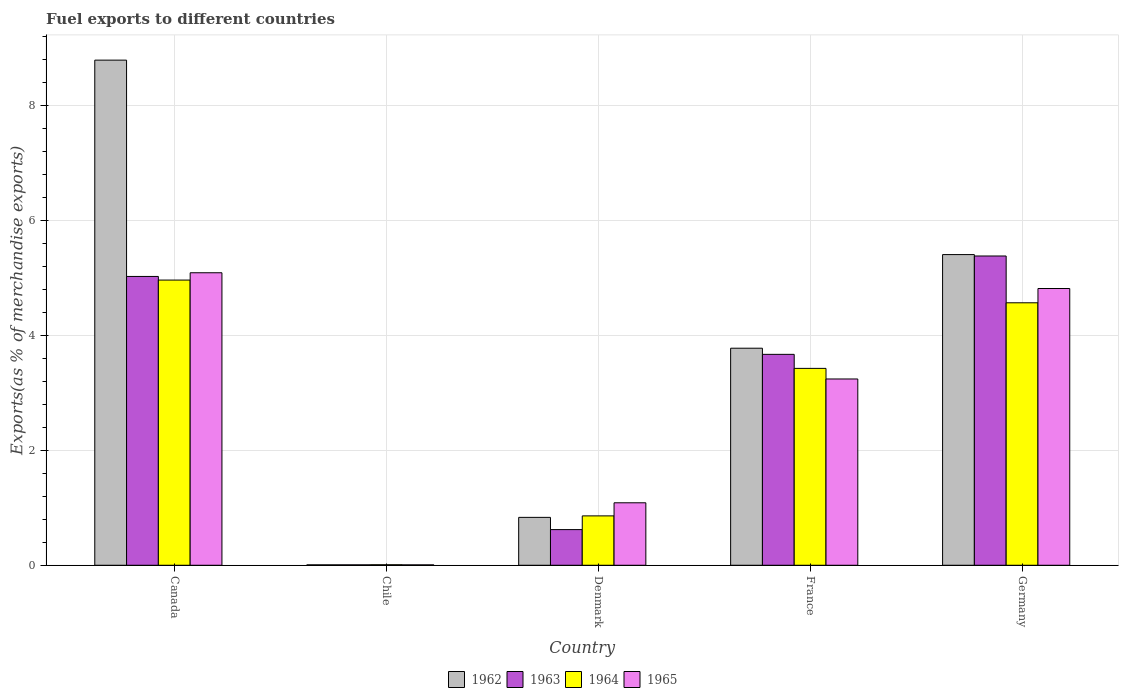Are the number of bars per tick equal to the number of legend labels?
Ensure brevity in your answer.  Yes. Are the number of bars on each tick of the X-axis equal?
Ensure brevity in your answer.  Yes. How many bars are there on the 3rd tick from the left?
Offer a very short reply. 4. How many bars are there on the 5th tick from the right?
Offer a terse response. 4. What is the label of the 1st group of bars from the left?
Keep it short and to the point. Canada. In how many cases, is the number of bars for a given country not equal to the number of legend labels?
Keep it short and to the point. 0. What is the percentage of exports to different countries in 1962 in Denmark?
Provide a succinct answer. 0.83. Across all countries, what is the maximum percentage of exports to different countries in 1963?
Your answer should be compact. 5.38. Across all countries, what is the minimum percentage of exports to different countries in 1965?
Offer a very short reply. 0.01. In which country was the percentage of exports to different countries in 1965 maximum?
Provide a succinct answer. Canada. What is the total percentage of exports to different countries in 1964 in the graph?
Your answer should be very brief. 13.82. What is the difference between the percentage of exports to different countries in 1963 in Canada and that in Germany?
Provide a short and direct response. -0.36. What is the difference between the percentage of exports to different countries in 1962 in Canada and the percentage of exports to different countries in 1963 in Chile?
Provide a short and direct response. 8.78. What is the average percentage of exports to different countries in 1962 per country?
Ensure brevity in your answer.  3.76. What is the difference between the percentage of exports to different countries of/in 1965 and percentage of exports to different countries of/in 1964 in Canada?
Your answer should be very brief. 0.13. What is the ratio of the percentage of exports to different countries in 1964 in Canada to that in Denmark?
Offer a very short reply. 5.78. Is the percentage of exports to different countries in 1965 in Chile less than that in France?
Provide a short and direct response. Yes. Is the difference between the percentage of exports to different countries in 1965 in France and Germany greater than the difference between the percentage of exports to different countries in 1964 in France and Germany?
Provide a succinct answer. No. What is the difference between the highest and the second highest percentage of exports to different countries in 1962?
Make the answer very short. 5.01. What is the difference between the highest and the lowest percentage of exports to different countries in 1963?
Your answer should be very brief. 5.37. In how many countries, is the percentage of exports to different countries in 1962 greater than the average percentage of exports to different countries in 1962 taken over all countries?
Your response must be concise. 3. Is it the case that in every country, the sum of the percentage of exports to different countries in 1962 and percentage of exports to different countries in 1963 is greater than the sum of percentage of exports to different countries in 1964 and percentage of exports to different countries in 1965?
Keep it short and to the point. No. What does the 2nd bar from the left in Canada represents?
Provide a succinct answer. 1963. Is it the case that in every country, the sum of the percentage of exports to different countries in 1962 and percentage of exports to different countries in 1964 is greater than the percentage of exports to different countries in 1965?
Provide a succinct answer. Yes. How many bars are there?
Your answer should be very brief. 20. What is the difference between two consecutive major ticks on the Y-axis?
Your answer should be very brief. 2. Are the values on the major ticks of Y-axis written in scientific E-notation?
Provide a succinct answer. No. Does the graph contain any zero values?
Offer a very short reply. No. Does the graph contain grids?
Offer a very short reply. Yes. How many legend labels are there?
Provide a short and direct response. 4. How are the legend labels stacked?
Ensure brevity in your answer.  Horizontal. What is the title of the graph?
Offer a terse response. Fuel exports to different countries. Does "1972" appear as one of the legend labels in the graph?
Make the answer very short. No. What is the label or title of the Y-axis?
Provide a short and direct response. Exports(as % of merchandise exports). What is the Exports(as % of merchandise exports) in 1962 in Canada?
Keep it short and to the point. 8.79. What is the Exports(as % of merchandise exports) in 1963 in Canada?
Give a very brief answer. 5.02. What is the Exports(as % of merchandise exports) of 1964 in Canada?
Keep it short and to the point. 4.96. What is the Exports(as % of merchandise exports) of 1965 in Canada?
Make the answer very short. 5.09. What is the Exports(as % of merchandise exports) in 1962 in Chile?
Your answer should be very brief. 0.01. What is the Exports(as % of merchandise exports) in 1963 in Chile?
Your answer should be very brief. 0.01. What is the Exports(as % of merchandise exports) in 1964 in Chile?
Keep it short and to the point. 0.01. What is the Exports(as % of merchandise exports) of 1965 in Chile?
Keep it short and to the point. 0.01. What is the Exports(as % of merchandise exports) of 1962 in Denmark?
Keep it short and to the point. 0.83. What is the Exports(as % of merchandise exports) of 1963 in Denmark?
Offer a terse response. 0.62. What is the Exports(as % of merchandise exports) in 1964 in Denmark?
Make the answer very short. 0.86. What is the Exports(as % of merchandise exports) in 1965 in Denmark?
Make the answer very short. 1.09. What is the Exports(as % of merchandise exports) of 1962 in France?
Keep it short and to the point. 3.78. What is the Exports(as % of merchandise exports) in 1963 in France?
Ensure brevity in your answer.  3.67. What is the Exports(as % of merchandise exports) of 1964 in France?
Your answer should be compact. 3.43. What is the Exports(as % of merchandise exports) of 1965 in France?
Keep it short and to the point. 3.24. What is the Exports(as % of merchandise exports) of 1962 in Germany?
Provide a short and direct response. 5.4. What is the Exports(as % of merchandise exports) in 1963 in Germany?
Provide a succinct answer. 5.38. What is the Exports(as % of merchandise exports) of 1964 in Germany?
Offer a terse response. 4.57. What is the Exports(as % of merchandise exports) of 1965 in Germany?
Make the answer very short. 4.81. Across all countries, what is the maximum Exports(as % of merchandise exports) in 1962?
Offer a very short reply. 8.79. Across all countries, what is the maximum Exports(as % of merchandise exports) in 1963?
Your answer should be compact. 5.38. Across all countries, what is the maximum Exports(as % of merchandise exports) of 1964?
Offer a terse response. 4.96. Across all countries, what is the maximum Exports(as % of merchandise exports) of 1965?
Keep it short and to the point. 5.09. Across all countries, what is the minimum Exports(as % of merchandise exports) of 1962?
Your answer should be compact. 0.01. Across all countries, what is the minimum Exports(as % of merchandise exports) of 1963?
Your response must be concise. 0.01. Across all countries, what is the minimum Exports(as % of merchandise exports) of 1964?
Your answer should be compact. 0.01. Across all countries, what is the minimum Exports(as % of merchandise exports) of 1965?
Offer a terse response. 0.01. What is the total Exports(as % of merchandise exports) of 1962 in the graph?
Give a very brief answer. 18.81. What is the total Exports(as % of merchandise exports) of 1963 in the graph?
Provide a short and direct response. 14.7. What is the total Exports(as % of merchandise exports) of 1964 in the graph?
Provide a short and direct response. 13.82. What is the total Exports(as % of merchandise exports) of 1965 in the graph?
Give a very brief answer. 14.24. What is the difference between the Exports(as % of merchandise exports) in 1962 in Canada and that in Chile?
Your answer should be very brief. 8.78. What is the difference between the Exports(as % of merchandise exports) of 1963 in Canada and that in Chile?
Offer a very short reply. 5.02. What is the difference between the Exports(as % of merchandise exports) in 1964 in Canada and that in Chile?
Offer a very short reply. 4.95. What is the difference between the Exports(as % of merchandise exports) in 1965 in Canada and that in Chile?
Provide a short and direct response. 5.08. What is the difference between the Exports(as % of merchandise exports) of 1962 in Canada and that in Denmark?
Your response must be concise. 7.95. What is the difference between the Exports(as % of merchandise exports) of 1963 in Canada and that in Denmark?
Your answer should be compact. 4.4. What is the difference between the Exports(as % of merchandise exports) of 1964 in Canada and that in Denmark?
Offer a terse response. 4.1. What is the difference between the Exports(as % of merchandise exports) in 1965 in Canada and that in Denmark?
Give a very brief answer. 4. What is the difference between the Exports(as % of merchandise exports) in 1962 in Canada and that in France?
Your answer should be very brief. 5.01. What is the difference between the Exports(as % of merchandise exports) in 1963 in Canada and that in France?
Give a very brief answer. 1.36. What is the difference between the Exports(as % of merchandise exports) in 1964 in Canada and that in France?
Keep it short and to the point. 1.54. What is the difference between the Exports(as % of merchandise exports) in 1965 in Canada and that in France?
Offer a very short reply. 1.85. What is the difference between the Exports(as % of merchandise exports) of 1962 in Canada and that in Germany?
Give a very brief answer. 3.38. What is the difference between the Exports(as % of merchandise exports) of 1963 in Canada and that in Germany?
Make the answer very short. -0.36. What is the difference between the Exports(as % of merchandise exports) in 1964 in Canada and that in Germany?
Keep it short and to the point. 0.4. What is the difference between the Exports(as % of merchandise exports) of 1965 in Canada and that in Germany?
Your answer should be compact. 0.27. What is the difference between the Exports(as % of merchandise exports) of 1962 in Chile and that in Denmark?
Your response must be concise. -0.83. What is the difference between the Exports(as % of merchandise exports) of 1963 in Chile and that in Denmark?
Provide a succinct answer. -0.61. What is the difference between the Exports(as % of merchandise exports) of 1964 in Chile and that in Denmark?
Offer a terse response. -0.85. What is the difference between the Exports(as % of merchandise exports) in 1965 in Chile and that in Denmark?
Offer a very short reply. -1.08. What is the difference between the Exports(as % of merchandise exports) of 1962 in Chile and that in France?
Provide a succinct answer. -3.77. What is the difference between the Exports(as % of merchandise exports) in 1963 in Chile and that in France?
Your answer should be compact. -3.66. What is the difference between the Exports(as % of merchandise exports) in 1964 in Chile and that in France?
Offer a very short reply. -3.42. What is the difference between the Exports(as % of merchandise exports) of 1965 in Chile and that in France?
Offer a terse response. -3.23. What is the difference between the Exports(as % of merchandise exports) of 1962 in Chile and that in Germany?
Keep it short and to the point. -5.4. What is the difference between the Exports(as % of merchandise exports) in 1963 in Chile and that in Germany?
Keep it short and to the point. -5.37. What is the difference between the Exports(as % of merchandise exports) in 1964 in Chile and that in Germany?
Your answer should be very brief. -4.56. What is the difference between the Exports(as % of merchandise exports) of 1965 in Chile and that in Germany?
Give a very brief answer. -4.81. What is the difference between the Exports(as % of merchandise exports) in 1962 in Denmark and that in France?
Your answer should be very brief. -2.94. What is the difference between the Exports(as % of merchandise exports) of 1963 in Denmark and that in France?
Keep it short and to the point. -3.05. What is the difference between the Exports(as % of merchandise exports) of 1964 in Denmark and that in France?
Your answer should be compact. -2.57. What is the difference between the Exports(as % of merchandise exports) in 1965 in Denmark and that in France?
Make the answer very short. -2.15. What is the difference between the Exports(as % of merchandise exports) in 1962 in Denmark and that in Germany?
Your answer should be very brief. -4.57. What is the difference between the Exports(as % of merchandise exports) of 1963 in Denmark and that in Germany?
Your answer should be very brief. -4.76. What is the difference between the Exports(as % of merchandise exports) in 1964 in Denmark and that in Germany?
Make the answer very short. -3.71. What is the difference between the Exports(as % of merchandise exports) of 1965 in Denmark and that in Germany?
Make the answer very short. -3.73. What is the difference between the Exports(as % of merchandise exports) in 1962 in France and that in Germany?
Provide a short and direct response. -1.63. What is the difference between the Exports(as % of merchandise exports) of 1963 in France and that in Germany?
Offer a very short reply. -1.71. What is the difference between the Exports(as % of merchandise exports) in 1964 in France and that in Germany?
Your response must be concise. -1.14. What is the difference between the Exports(as % of merchandise exports) in 1965 in France and that in Germany?
Provide a succinct answer. -1.57. What is the difference between the Exports(as % of merchandise exports) in 1962 in Canada and the Exports(as % of merchandise exports) in 1963 in Chile?
Your answer should be very brief. 8.78. What is the difference between the Exports(as % of merchandise exports) of 1962 in Canada and the Exports(as % of merchandise exports) of 1964 in Chile?
Ensure brevity in your answer.  8.78. What is the difference between the Exports(as % of merchandise exports) of 1962 in Canada and the Exports(as % of merchandise exports) of 1965 in Chile?
Offer a terse response. 8.78. What is the difference between the Exports(as % of merchandise exports) in 1963 in Canada and the Exports(as % of merchandise exports) in 1964 in Chile?
Your response must be concise. 5.02. What is the difference between the Exports(as % of merchandise exports) of 1963 in Canada and the Exports(as % of merchandise exports) of 1965 in Chile?
Ensure brevity in your answer.  5.02. What is the difference between the Exports(as % of merchandise exports) of 1964 in Canada and the Exports(as % of merchandise exports) of 1965 in Chile?
Offer a terse response. 4.95. What is the difference between the Exports(as % of merchandise exports) in 1962 in Canada and the Exports(as % of merchandise exports) in 1963 in Denmark?
Offer a very short reply. 8.17. What is the difference between the Exports(as % of merchandise exports) in 1962 in Canada and the Exports(as % of merchandise exports) in 1964 in Denmark?
Your answer should be compact. 7.93. What is the difference between the Exports(as % of merchandise exports) of 1962 in Canada and the Exports(as % of merchandise exports) of 1965 in Denmark?
Your response must be concise. 7.7. What is the difference between the Exports(as % of merchandise exports) of 1963 in Canada and the Exports(as % of merchandise exports) of 1964 in Denmark?
Keep it short and to the point. 4.17. What is the difference between the Exports(as % of merchandise exports) of 1963 in Canada and the Exports(as % of merchandise exports) of 1965 in Denmark?
Provide a short and direct response. 3.94. What is the difference between the Exports(as % of merchandise exports) in 1964 in Canada and the Exports(as % of merchandise exports) in 1965 in Denmark?
Your answer should be compact. 3.87. What is the difference between the Exports(as % of merchandise exports) of 1962 in Canada and the Exports(as % of merchandise exports) of 1963 in France?
Give a very brief answer. 5.12. What is the difference between the Exports(as % of merchandise exports) in 1962 in Canada and the Exports(as % of merchandise exports) in 1964 in France?
Your answer should be compact. 5.36. What is the difference between the Exports(as % of merchandise exports) of 1962 in Canada and the Exports(as % of merchandise exports) of 1965 in France?
Make the answer very short. 5.55. What is the difference between the Exports(as % of merchandise exports) of 1963 in Canada and the Exports(as % of merchandise exports) of 1964 in France?
Keep it short and to the point. 1.6. What is the difference between the Exports(as % of merchandise exports) of 1963 in Canada and the Exports(as % of merchandise exports) of 1965 in France?
Keep it short and to the point. 1.78. What is the difference between the Exports(as % of merchandise exports) in 1964 in Canada and the Exports(as % of merchandise exports) in 1965 in France?
Keep it short and to the point. 1.72. What is the difference between the Exports(as % of merchandise exports) in 1962 in Canada and the Exports(as % of merchandise exports) in 1963 in Germany?
Your answer should be very brief. 3.41. What is the difference between the Exports(as % of merchandise exports) in 1962 in Canada and the Exports(as % of merchandise exports) in 1964 in Germany?
Your response must be concise. 4.22. What is the difference between the Exports(as % of merchandise exports) in 1962 in Canada and the Exports(as % of merchandise exports) in 1965 in Germany?
Provide a succinct answer. 3.97. What is the difference between the Exports(as % of merchandise exports) of 1963 in Canada and the Exports(as % of merchandise exports) of 1964 in Germany?
Keep it short and to the point. 0.46. What is the difference between the Exports(as % of merchandise exports) of 1963 in Canada and the Exports(as % of merchandise exports) of 1965 in Germany?
Your response must be concise. 0.21. What is the difference between the Exports(as % of merchandise exports) of 1964 in Canada and the Exports(as % of merchandise exports) of 1965 in Germany?
Ensure brevity in your answer.  0.15. What is the difference between the Exports(as % of merchandise exports) in 1962 in Chile and the Exports(as % of merchandise exports) in 1963 in Denmark?
Provide a short and direct response. -0.61. What is the difference between the Exports(as % of merchandise exports) of 1962 in Chile and the Exports(as % of merchandise exports) of 1964 in Denmark?
Your answer should be compact. -0.85. What is the difference between the Exports(as % of merchandise exports) of 1962 in Chile and the Exports(as % of merchandise exports) of 1965 in Denmark?
Offer a very short reply. -1.08. What is the difference between the Exports(as % of merchandise exports) of 1963 in Chile and the Exports(as % of merchandise exports) of 1964 in Denmark?
Offer a very short reply. -0.85. What is the difference between the Exports(as % of merchandise exports) of 1963 in Chile and the Exports(as % of merchandise exports) of 1965 in Denmark?
Your answer should be very brief. -1.08. What is the difference between the Exports(as % of merchandise exports) of 1964 in Chile and the Exports(as % of merchandise exports) of 1965 in Denmark?
Ensure brevity in your answer.  -1.08. What is the difference between the Exports(as % of merchandise exports) of 1962 in Chile and the Exports(as % of merchandise exports) of 1963 in France?
Keep it short and to the point. -3.66. What is the difference between the Exports(as % of merchandise exports) in 1962 in Chile and the Exports(as % of merchandise exports) in 1964 in France?
Offer a very short reply. -3.42. What is the difference between the Exports(as % of merchandise exports) in 1962 in Chile and the Exports(as % of merchandise exports) in 1965 in France?
Offer a very short reply. -3.23. What is the difference between the Exports(as % of merchandise exports) in 1963 in Chile and the Exports(as % of merchandise exports) in 1964 in France?
Provide a short and direct response. -3.42. What is the difference between the Exports(as % of merchandise exports) of 1963 in Chile and the Exports(as % of merchandise exports) of 1965 in France?
Offer a very short reply. -3.23. What is the difference between the Exports(as % of merchandise exports) of 1964 in Chile and the Exports(as % of merchandise exports) of 1965 in France?
Your answer should be very brief. -3.23. What is the difference between the Exports(as % of merchandise exports) of 1962 in Chile and the Exports(as % of merchandise exports) of 1963 in Germany?
Your answer should be compact. -5.37. What is the difference between the Exports(as % of merchandise exports) in 1962 in Chile and the Exports(as % of merchandise exports) in 1964 in Germany?
Provide a succinct answer. -4.56. What is the difference between the Exports(as % of merchandise exports) of 1962 in Chile and the Exports(as % of merchandise exports) of 1965 in Germany?
Your answer should be very brief. -4.81. What is the difference between the Exports(as % of merchandise exports) in 1963 in Chile and the Exports(as % of merchandise exports) in 1964 in Germany?
Provide a succinct answer. -4.56. What is the difference between the Exports(as % of merchandise exports) in 1963 in Chile and the Exports(as % of merchandise exports) in 1965 in Germany?
Keep it short and to the point. -4.81. What is the difference between the Exports(as % of merchandise exports) of 1964 in Chile and the Exports(as % of merchandise exports) of 1965 in Germany?
Keep it short and to the point. -4.81. What is the difference between the Exports(as % of merchandise exports) in 1962 in Denmark and the Exports(as % of merchandise exports) in 1963 in France?
Provide a succinct answer. -2.84. What is the difference between the Exports(as % of merchandise exports) in 1962 in Denmark and the Exports(as % of merchandise exports) in 1964 in France?
Your response must be concise. -2.59. What is the difference between the Exports(as % of merchandise exports) in 1962 in Denmark and the Exports(as % of merchandise exports) in 1965 in France?
Offer a very short reply. -2.41. What is the difference between the Exports(as % of merchandise exports) of 1963 in Denmark and the Exports(as % of merchandise exports) of 1964 in France?
Provide a succinct answer. -2.8. What is the difference between the Exports(as % of merchandise exports) in 1963 in Denmark and the Exports(as % of merchandise exports) in 1965 in France?
Keep it short and to the point. -2.62. What is the difference between the Exports(as % of merchandise exports) of 1964 in Denmark and the Exports(as % of merchandise exports) of 1965 in France?
Give a very brief answer. -2.38. What is the difference between the Exports(as % of merchandise exports) of 1962 in Denmark and the Exports(as % of merchandise exports) of 1963 in Germany?
Your answer should be very brief. -4.55. What is the difference between the Exports(as % of merchandise exports) of 1962 in Denmark and the Exports(as % of merchandise exports) of 1964 in Germany?
Your response must be concise. -3.73. What is the difference between the Exports(as % of merchandise exports) of 1962 in Denmark and the Exports(as % of merchandise exports) of 1965 in Germany?
Make the answer very short. -3.98. What is the difference between the Exports(as % of merchandise exports) in 1963 in Denmark and the Exports(as % of merchandise exports) in 1964 in Germany?
Provide a short and direct response. -3.95. What is the difference between the Exports(as % of merchandise exports) in 1963 in Denmark and the Exports(as % of merchandise exports) in 1965 in Germany?
Your answer should be very brief. -4.19. What is the difference between the Exports(as % of merchandise exports) of 1964 in Denmark and the Exports(as % of merchandise exports) of 1965 in Germany?
Make the answer very short. -3.96. What is the difference between the Exports(as % of merchandise exports) in 1962 in France and the Exports(as % of merchandise exports) in 1963 in Germany?
Provide a short and direct response. -1.6. What is the difference between the Exports(as % of merchandise exports) in 1962 in France and the Exports(as % of merchandise exports) in 1964 in Germany?
Offer a terse response. -0.79. What is the difference between the Exports(as % of merchandise exports) of 1962 in France and the Exports(as % of merchandise exports) of 1965 in Germany?
Offer a terse response. -1.04. What is the difference between the Exports(as % of merchandise exports) of 1963 in France and the Exports(as % of merchandise exports) of 1964 in Germany?
Provide a succinct answer. -0.9. What is the difference between the Exports(as % of merchandise exports) in 1963 in France and the Exports(as % of merchandise exports) in 1965 in Germany?
Give a very brief answer. -1.15. What is the difference between the Exports(as % of merchandise exports) in 1964 in France and the Exports(as % of merchandise exports) in 1965 in Germany?
Give a very brief answer. -1.39. What is the average Exports(as % of merchandise exports) in 1962 per country?
Keep it short and to the point. 3.76. What is the average Exports(as % of merchandise exports) in 1963 per country?
Ensure brevity in your answer.  2.94. What is the average Exports(as % of merchandise exports) in 1964 per country?
Provide a short and direct response. 2.76. What is the average Exports(as % of merchandise exports) in 1965 per country?
Keep it short and to the point. 2.85. What is the difference between the Exports(as % of merchandise exports) of 1962 and Exports(as % of merchandise exports) of 1963 in Canada?
Provide a short and direct response. 3.76. What is the difference between the Exports(as % of merchandise exports) of 1962 and Exports(as % of merchandise exports) of 1964 in Canada?
Ensure brevity in your answer.  3.83. What is the difference between the Exports(as % of merchandise exports) in 1962 and Exports(as % of merchandise exports) in 1965 in Canada?
Your answer should be compact. 3.7. What is the difference between the Exports(as % of merchandise exports) in 1963 and Exports(as % of merchandise exports) in 1964 in Canada?
Your response must be concise. 0.06. What is the difference between the Exports(as % of merchandise exports) of 1963 and Exports(as % of merchandise exports) of 1965 in Canada?
Offer a terse response. -0.06. What is the difference between the Exports(as % of merchandise exports) in 1964 and Exports(as % of merchandise exports) in 1965 in Canada?
Your response must be concise. -0.13. What is the difference between the Exports(as % of merchandise exports) of 1962 and Exports(as % of merchandise exports) of 1963 in Chile?
Your answer should be compact. -0. What is the difference between the Exports(as % of merchandise exports) of 1962 and Exports(as % of merchandise exports) of 1964 in Chile?
Provide a short and direct response. -0. What is the difference between the Exports(as % of merchandise exports) in 1962 and Exports(as % of merchandise exports) in 1965 in Chile?
Your answer should be compact. 0. What is the difference between the Exports(as % of merchandise exports) of 1963 and Exports(as % of merchandise exports) of 1964 in Chile?
Keep it short and to the point. -0. What is the difference between the Exports(as % of merchandise exports) in 1964 and Exports(as % of merchandise exports) in 1965 in Chile?
Offer a very short reply. 0. What is the difference between the Exports(as % of merchandise exports) in 1962 and Exports(as % of merchandise exports) in 1963 in Denmark?
Your answer should be compact. 0.21. What is the difference between the Exports(as % of merchandise exports) of 1962 and Exports(as % of merchandise exports) of 1964 in Denmark?
Give a very brief answer. -0.03. What is the difference between the Exports(as % of merchandise exports) in 1962 and Exports(as % of merchandise exports) in 1965 in Denmark?
Offer a very short reply. -0.25. What is the difference between the Exports(as % of merchandise exports) of 1963 and Exports(as % of merchandise exports) of 1964 in Denmark?
Your answer should be compact. -0.24. What is the difference between the Exports(as % of merchandise exports) in 1963 and Exports(as % of merchandise exports) in 1965 in Denmark?
Provide a short and direct response. -0.47. What is the difference between the Exports(as % of merchandise exports) of 1964 and Exports(as % of merchandise exports) of 1965 in Denmark?
Your answer should be very brief. -0.23. What is the difference between the Exports(as % of merchandise exports) of 1962 and Exports(as % of merchandise exports) of 1963 in France?
Provide a succinct answer. 0.11. What is the difference between the Exports(as % of merchandise exports) of 1962 and Exports(as % of merchandise exports) of 1964 in France?
Provide a short and direct response. 0.35. What is the difference between the Exports(as % of merchandise exports) of 1962 and Exports(as % of merchandise exports) of 1965 in France?
Give a very brief answer. 0.54. What is the difference between the Exports(as % of merchandise exports) in 1963 and Exports(as % of merchandise exports) in 1964 in France?
Keep it short and to the point. 0.24. What is the difference between the Exports(as % of merchandise exports) in 1963 and Exports(as % of merchandise exports) in 1965 in France?
Give a very brief answer. 0.43. What is the difference between the Exports(as % of merchandise exports) of 1964 and Exports(as % of merchandise exports) of 1965 in France?
Your response must be concise. 0.18. What is the difference between the Exports(as % of merchandise exports) of 1962 and Exports(as % of merchandise exports) of 1963 in Germany?
Provide a short and direct response. 0.02. What is the difference between the Exports(as % of merchandise exports) in 1962 and Exports(as % of merchandise exports) in 1964 in Germany?
Provide a short and direct response. 0.84. What is the difference between the Exports(as % of merchandise exports) of 1962 and Exports(as % of merchandise exports) of 1965 in Germany?
Make the answer very short. 0.59. What is the difference between the Exports(as % of merchandise exports) of 1963 and Exports(as % of merchandise exports) of 1964 in Germany?
Offer a terse response. 0.81. What is the difference between the Exports(as % of merchandise exports) of 1963 and Exports(as % of merchandise exports) of 1965 in Germany?
Your response must be concise. 0.57. What is the difference between the Exports(as % of merchandise exports) in 1964 and Exports(as % of merchandise exports) in 1965 in Germany?
Your response must be concise. -0.25. What is the ratio of the Exports(as % of merchandise exports) of 1962 in Canada to that in Chile?
Provide a short and direct response. 1254.38. What is the ratio of the Exports(as % of merchandise exports) in 1963 in Canada to that in Chile?
Ensure brevity in your answer.  709.22. What is the ratio of the Exports(as % of merchandise exports) of 1964 in Canada to that in Chile?
Offer a very short reply. 555.45. What is the ratio of the Exports(as % of merchandise exports) in 1965 in Canada to that in Chile?
Offer a very short reply. 752.83. What is the ratio of the Exports(as % of merchandise exports) in 1962 in Canada to that in Denmark?
Offer a very short reply. 10.55. What is the ratio of the Exports(as % of merchandise exports) of 1963 in Canada to that in Denmark?
Give a very brief answer. 8.1. What is the ratio of the Exports(as % of merchandise exports) of 1964 in Canada to that in Denmark?
Make the answer very short. 5.78. What is the ratio of the Exports(as % of merchandise exports) in 1965 in Canada to that in Denmark?
Your response must be concise. 4.68. What is the ratio of the Exports(as % of merchandise exports) of 1962 in Canada to that in France?
Offer a terse response. 2.33. What is the ratio of the Exports(as % of merchandise exports) in 1963 in Canada to that in France?
Your response must be concise. 1.37. What is the ratio of the Exports(as % of merchandise exports) of 1964 in Canada to that in France?
Your answer should be compact. 1.45. What is the ratio of the Exports(as % of merchandise exports) in 1965 in Canada to that in France?
Provide a short and direct response. 1.57. What is the ratio of the Exports(as % of merchandise exports) of 1962 in Canada to that in Germany?
Offer a very short reply. 1.63. What is the ratio of the Exports(as % of merchandise exports) in 1963 in Canada to that in Germany?
Your answer should be compact. 0.93. What is the ratio of the Exports(as % of merchandise exports) of 1964 in Canada to that in Germany?
Offer a terse response. 1.09. What is the ratio of the Exports(as % of merchandise exports) of 1965 in Canada to that in Germany?
Provide a short and direct response. 1.06. What is the ratio of the Exports(as % of merchandise exports) of 1962 in Chile to that in Denmark?
Your answer should be compact. 0.01. What is the ratio of the Exports(as % of merchandise exports) of 1963 in Chile to that in Denmark?
Your answer should be very brief. 0.01. What is the ratio of the Exports(as % of merchandise exports) in 1964 in Chile to that in Denmark?
Offer a terse response. 0.01. What is the ratio of the Exports(as % of merchandise exports) in 1965 in Chile to that in Denmark?
Provide a succinct answer. 0.01. What is the ratio of the Exports(as % of merchandise exports) in 1962 in Chile to that in France?
Your answer should be compact. 0. What is the ratio of the Exports(as % of merchandise exports) in 1963 in Chile to that in France?
Give a very brief answer. 0. What is the ratio of the Exports(as % of merchandise exports) in 1964 in Chile to that in France?
Give a very brief answer. 0. What is the ratio of the Exports(as % of merchandise exports) in 1965 in Chile to that in France?
Offer a very short reply. 0. What is the ratio of the Exports(as % of merchandise exports) in 1962 in Chile to that in Germany?
Give a very brief answer. 0. What is the ratio of the Exports(as % of merchandise exports) in 1963 in Chile to that in Germany?
Provide a succinct answer. 0. What is the ratio of the Exports(as % of merchandise exports) of 1964 in Chile to that in Germany?
Your answer should be compact. 0. What is the ratio of the Exports(as % of merchandise exports) in 1965 in Chile to that in Germany?
Offer a very short reply. 0. What is the ratio of the Exports(as % of merchandise exports) of 1962 in Denmark to that in France?
Make the answer very short. 0.22. What is the ratio of the Exports(as % of merchandise exports) in 1963 in Denmark to that in France?
Provide a short and direct response. 0.17. What is the ratio of the Exports(as % of merchandise exports) in 1964 in Denmark to that in France?
Offer a very short reply. 0.25. What is the ratio of the Exports(as % of merchandise exports) of 1965 in Denmark to that in France?
Ensure brevity in your answer.  0.34. What is the ratio of the Exports(as % of merchandise exports) in 1962 in Denmark to that in Germany?
Your answer should be compact. 0.15. What is the ratio of the Exports(as % of merchandise exports) of 1963 in Denmark to that in Germany?
Offer a terse response. 0.12. What is the ratio of the Exports(as % of merchandise exports) in 1964 in Denmark to that in Germany?
Your answer should be very brief. 0.19. What is the ratio of the Exports(as % of merchandise exports) of 1965 in Denmark to that in Germany?
Give a very brief answer. 0.23. What is the ratio of the Exports(as % of merchandise exports) of 1962 in France to that in Germany?
Give a very brief answer. 0.7. What is the ratio of the Exports(as % of merchandise exports) of 1963 in France to that in Germany?
Your response must be concise. 0.68. What is the ratio of the Exports(as % of merchandise exports) in 1964 in France to that in Germany?
Provide a succinct answer. 0.75. What is the ratio of the Exports(as % of merchandise exports) in 1965 in France to that in Germany?
Offer a very short reply. 0.67. What is the difference between the highest and the second highest Exports(as % of merchandise exports) in 1962?
Ensure brevity in your answer.  3.38. What is the difference between the highest and the second highest Exports(as % of merchandise exports) in 1963?
Ensure brevity in your answer.  0.36. What is the difference between the highest and the second highest Exports(as % of merchandise exports) of 1964?
Make the answer very short. 0.4. What is the difference between the highest and the second highest Exports(as % of merchandise exports) of 1965?
Your answer should be compact. 0.27. What is the difference between the highest and the lowest Exports(as % of merchandise exports) in 1962?
Your response must be concise. 8.78. What is the difference between the highest and the lowest Exports(as % of merchandise exports) of 1963?
Offer a terse response. 5.37. What is the difference between the highest and the lowest Exports(as % of merchandise exports) in 1964?
Ensure brevity in your answer.  4.95. What is the difference between the highest and the lowest Exports(as % of merchandise exports) in 1965?
Ensure brevity in your answer.  5.08. 